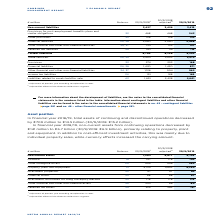According to Metro Ag's financial document, What was the column '30/9/2018 adjusted' adjusted for? Adjusted for effects of the discontinued business segment.. The document states: "2 Adjusted for effects of the discontinued business segment...." Also, How much did the total assets of continuing and discontinued operations change by in FY2019? decreased by €709 million to €14.5 billion (30/9/2018: €15.2 billion).. The document states: "l assets of continuing and discontinued operations decreased by €709 million to €14.5 billion (30/9/2018: €15.2 billion). In financial year 2018/19, n..." Also, In which years was the amount of non-current assets recorded in? The document shows two values: 2019 and 2018. From the document: "adjusted 2 30/9/2019 € million Note no. 30/9/2018 1 30/9/2018..." Also, can you calculate: What is the difference in Goodwill and other intangible assets for FY2019? Based on the calculation:  785 - 562 , the result is 223 (in millions). This is based on the information: "Goodwill 19 797 778 785 Other intangible assets 20 499 496 562..." The key data points involved are: 562, 785. Also, can you calculate: What was the change in deferred tax assets in FY2019 from FY2018 adjusted? Based on the calculation: 191-262, the result is -71 (in millions). This is based on the information: "Deferred tax assets 25 329 262 191 Deferred tax assets 25 329 262 191..." The key data points involved are: 191, 262. Also, can you calculate: What was the percentage change in deferred tax assets in FY2019 from FY2018 adjusted? To answer this question, I need to perform calculations using the financial data. The calculation is: (191-262)/262, which equals -27.1 (percentage). This is based on the information: "Deferred tax assets 25 329 262 191 Deferred tax assets 25 329 262 191..." The key data points involved are: 191, 262. 